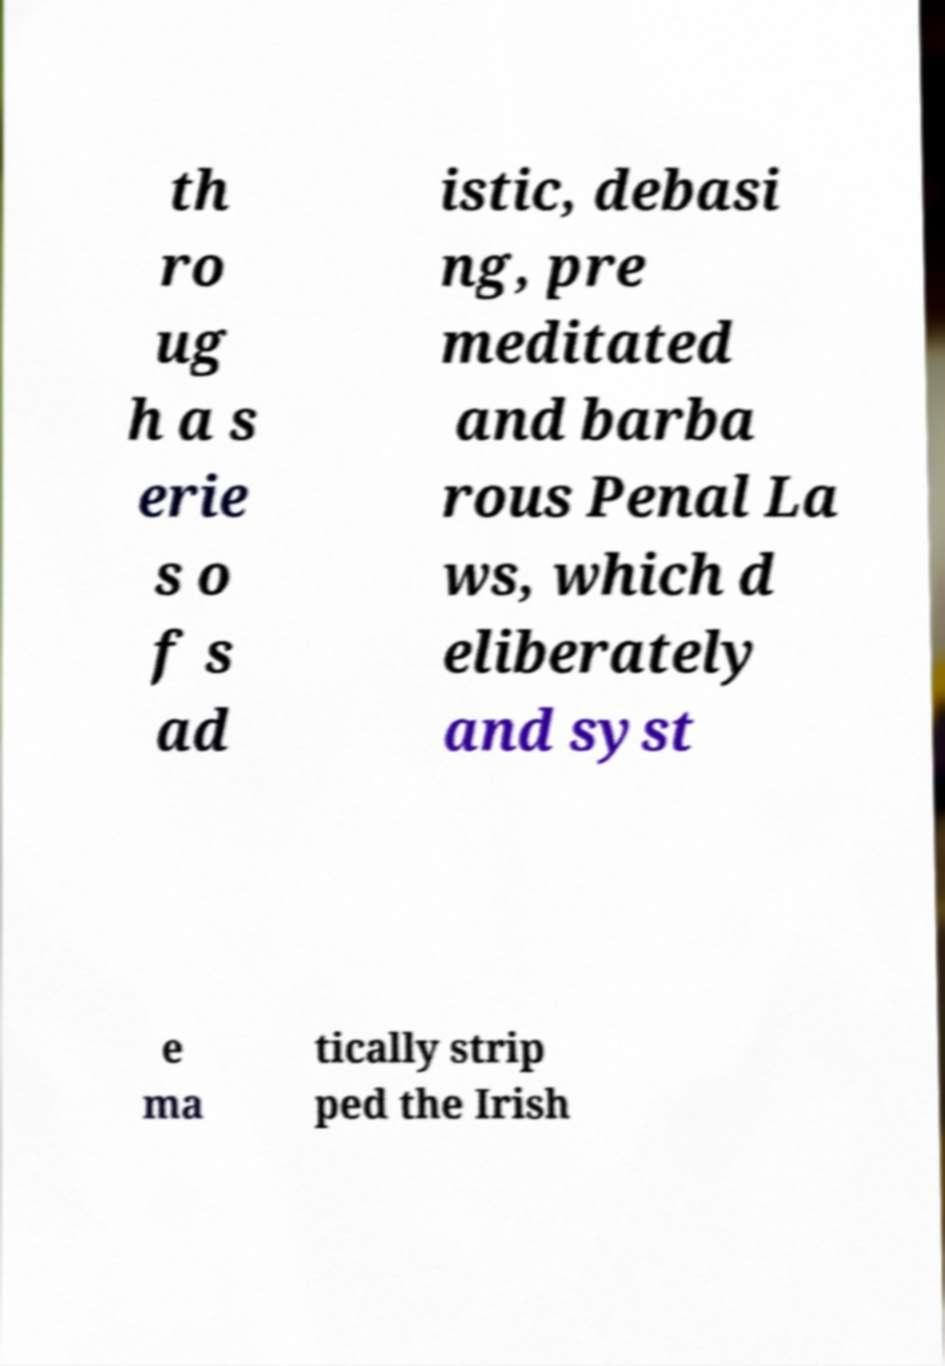What messages or text are displayed in this image? I need them in a readable, typed format. th ro ug h a s erie s o f s ad istic, debasi ng, pre meditated and barba rous Penal La ws, which d eliberately and syst e ma tically strip ped the Irish 